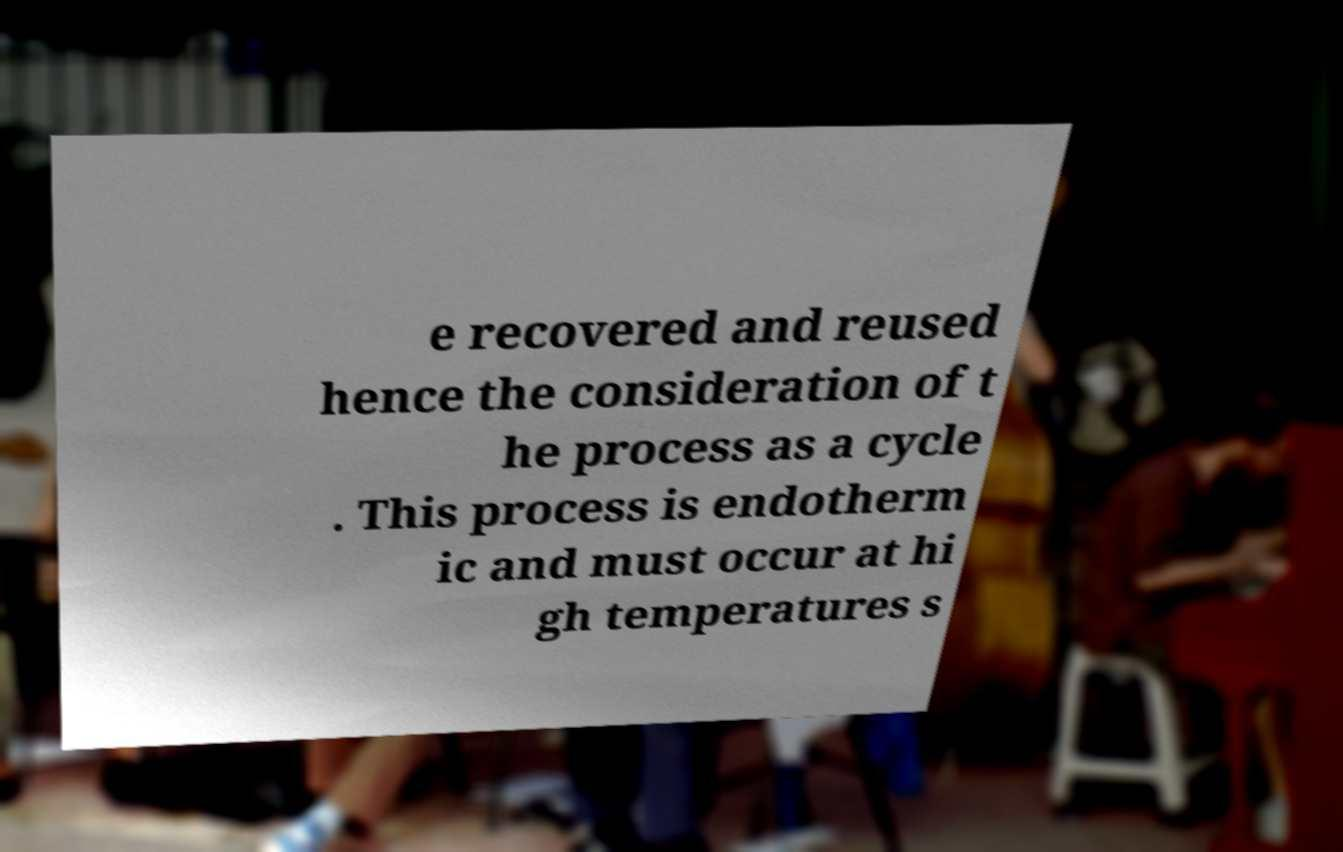Can you read and provide the text displayed in the image?This photo seems to have some interesting text. Can you extract and type it out for me? e recovered and reused hence the consideration of t he process as a cycle . This process is endotherm ic and must occur at hi gh temperatures s 